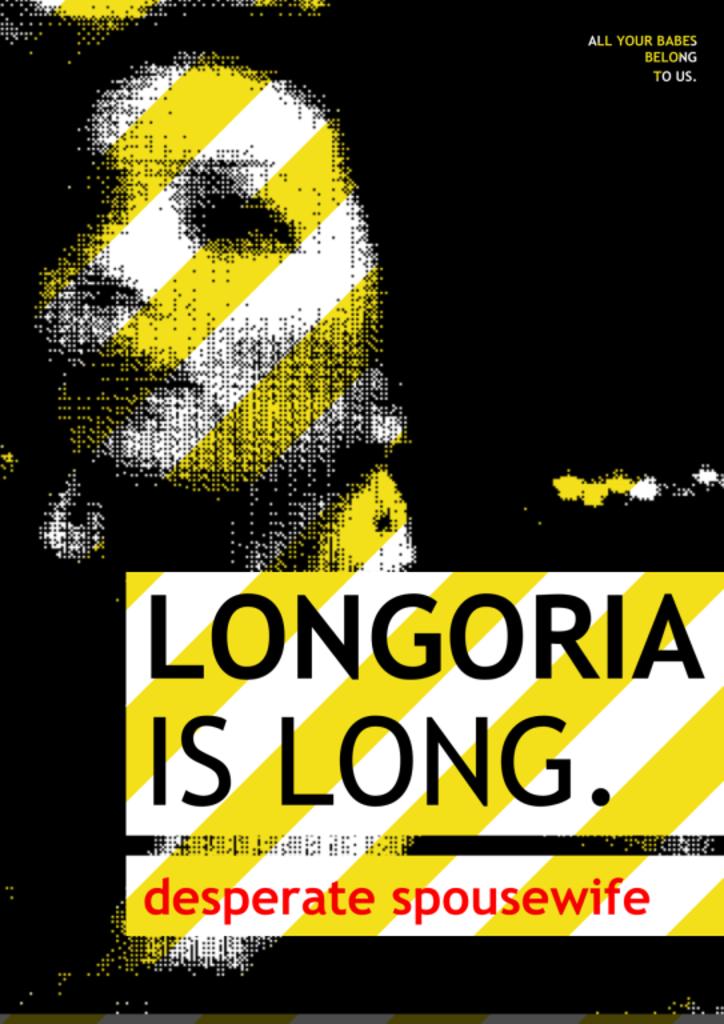Is this about the show desperate housewives?
Offer a terse response. Yes. 